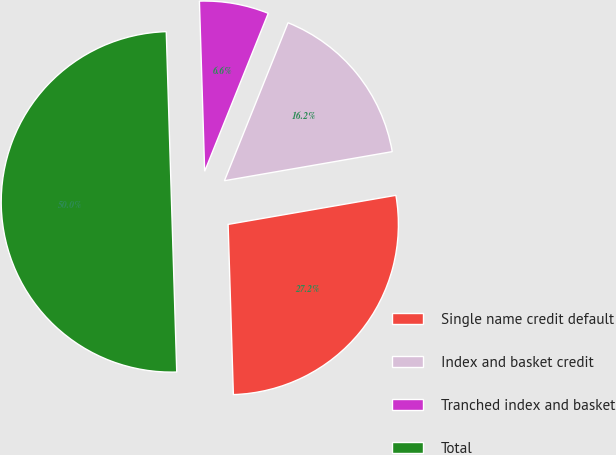Convert chart. <chart><loc_0><loc_0><loc_500><loc_500><pie_chart><fcel>Single name credit default<fcel>Index and basket credit<fcel>Tranched index and basket<fcel>Total<nl><fcel>27.24%<fcel>16.18%<fcel>6.58%<fcel>50.0%<nl></chart> 